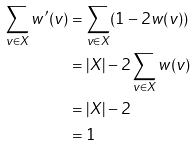Convert formula to latex. <formula><loc_0><loc_0><loc_500><loc_500>\sum _ { v \in X } w ^ { \prime } ( v ) & = \sum _ { v \in X } ( 1 - 2 w ( v ) ) \\ & = | X | - 2 \sum _ { v \in X } w ( v ) \\ & = | X | - 2 \\ & = 1</formula> 